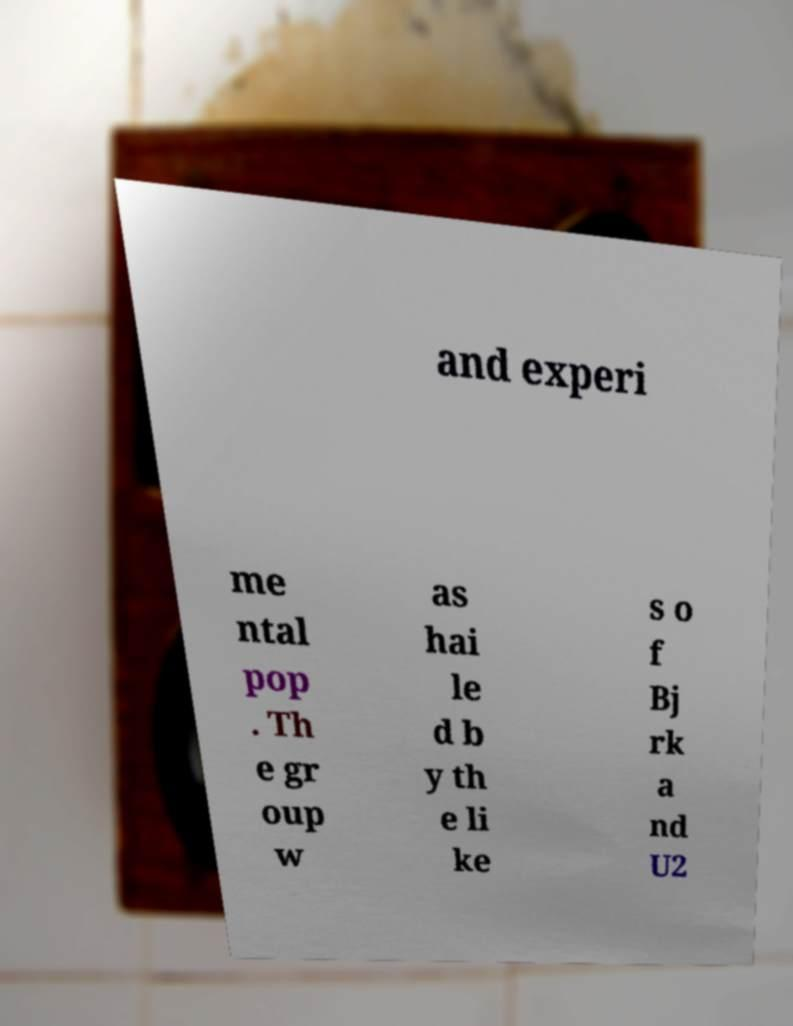Please read and relay the text visible in this image. What does it say? and experi me ntal pop . Th e gr oup w as hai le d b y th e li ke s o f Bj rk a nd U2 